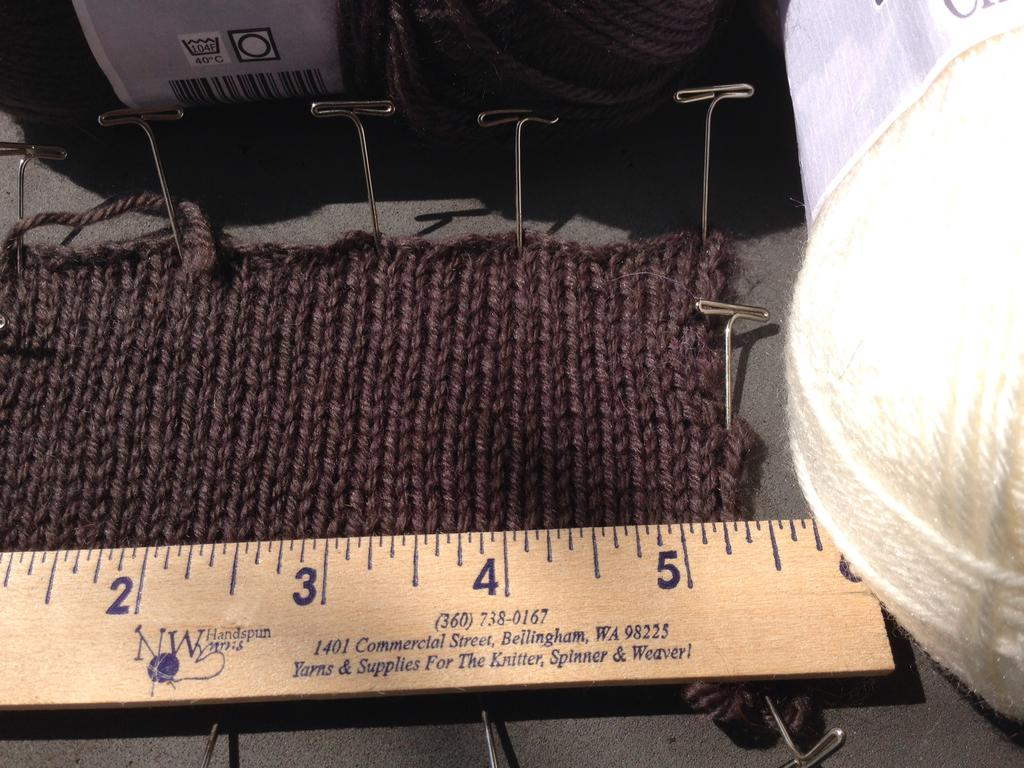<image>
Summarize the visual content of the image. Brown ruler that says the number 3607380167 on the bottom. 